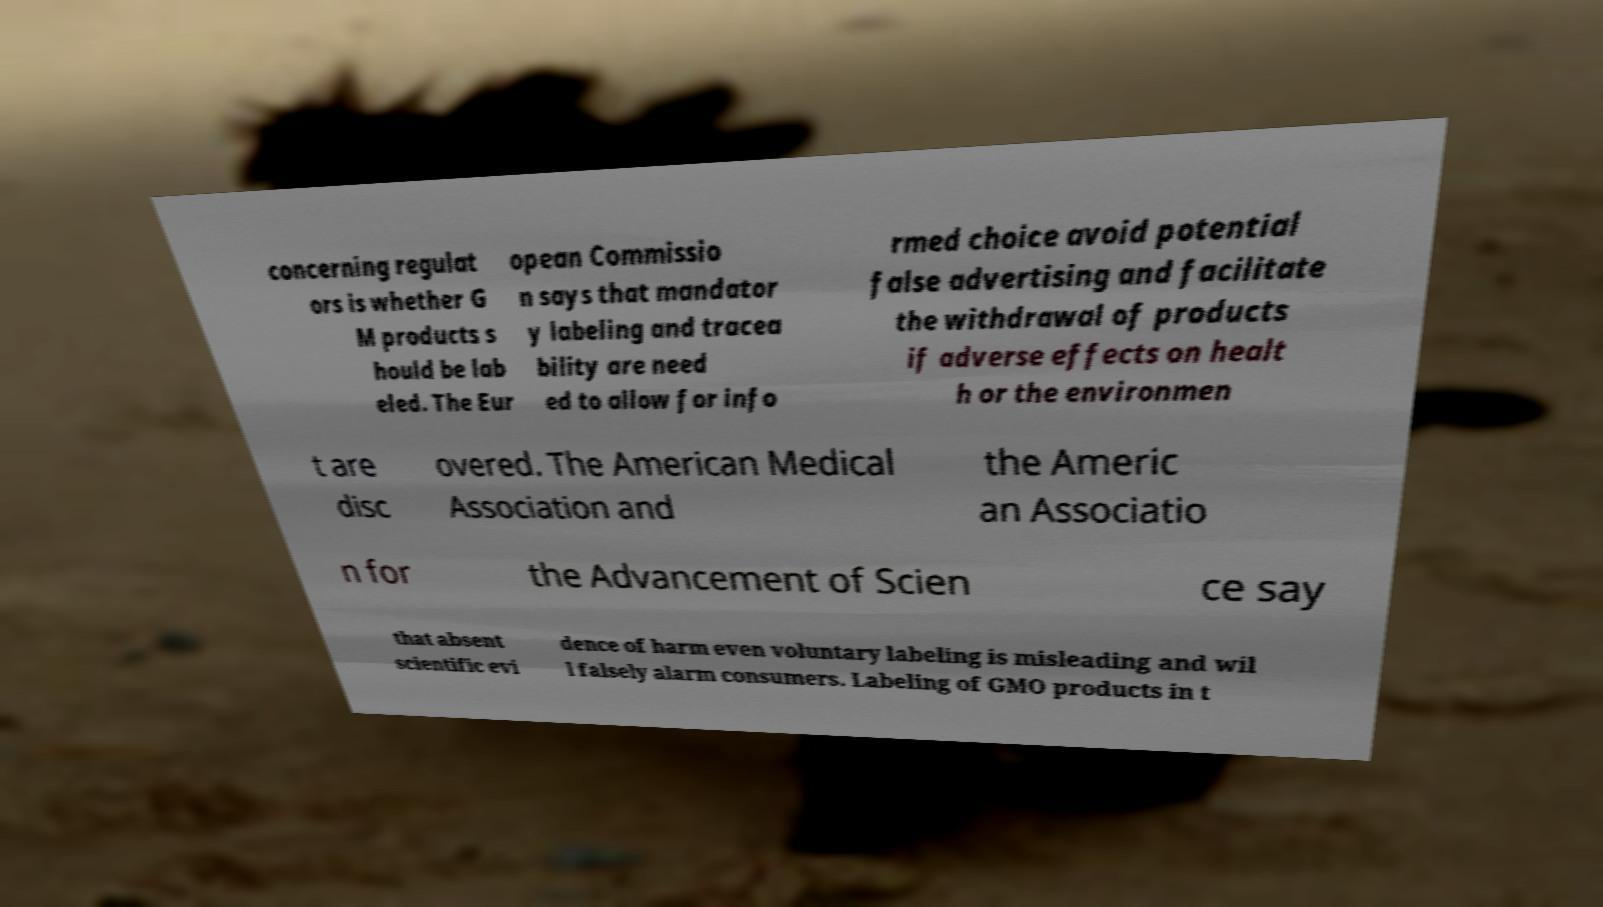Please identify and transcribe the text found in this image. concerning regulat ors is whether G M products s hould be lab eled. The Eur opean Commissio n says that mandator y labeling and tracea bility are need ed to allow for info rmed choice avoid potential false advertising and facilitate the withdrawal of products if adverse effects on healt h or the environmen t are disc overed. The American Medical Association and the Americ an Associatio n for the Advancement of Scien ce say that absent scientific evi dence of harm even voluntary labeling is misleading and wil l falsely alarm consumers. Labeling of GMO products in t 